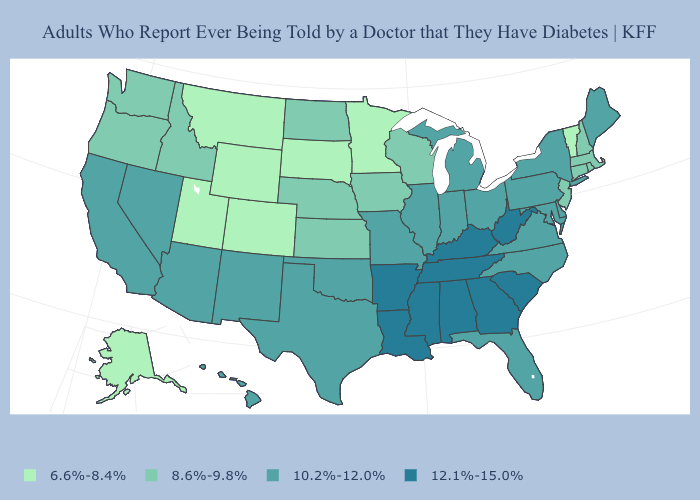Does the first symbol in the legend represent the smallest category?
Quick response, please. Yes. Does the map have missing data?
Keep it brief. No. Does Vermont have the lowest value in the Northeast?
Quick response, please. Yes. Is the legend a continuous bar?
Give a very brief answer. No. Name the states that have a value in the range 6.6%-8.4%?
Answer briefly. Alaska, Colorado, Minnesota, Montana, South Dakota, Utah, Vermont, Wyoming. Name the states that have a value in the range 6.6%-8.4%?
Keep it brief. Alaska, Colorado, Minnesota, Montana, South Dakota, Utah, Vermont, Wyoming. Name the states that have a value in the range 12.1%-15.0%?
Give a very brief answer. Alabama, Arkansas, Georgia, Kentucky, Louisiana, Mississippi, South Carolina, Tennessee, West Virginia. Among the states that border Kentucky , which have the lowest value?
Give a very brief answer. Illinois, Indiana, Missouri, Ohio, Virginia. Does the first symbol in the legend represent the smallest category?
Give a very brief answer. Yes. What is the value of Arkansas?
Keep it brief. 12.1%-15.0%. Which states hav the highest value in the MidWest?
Short answer required. Illinois, Indiana, Michigan, Missouri, Ohio. What is the value of Mississippi?
Concise answer only. 12.1%-15.0%. Name the states that have a value in the range 8.6%-9.8%?
Write a very short answer. Connecticut, Idaho, Iowa, Kansas, Massachusetts, Nebraska, New Hampshire, New Jersey, North Dakota, Oregon, Rhode Island, Washington, Wisconsin. Does Pennsylvania have the same value as Rhode Island?
Be succinct. No. What is the value of Vermont?
Concise answer only. 6.6%-8.4%. 